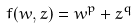<formula> <loc_0><loc_0><loc_500><loc_500>f ( w , z ) = w ^ { p } + z ^ { q }</formula> 